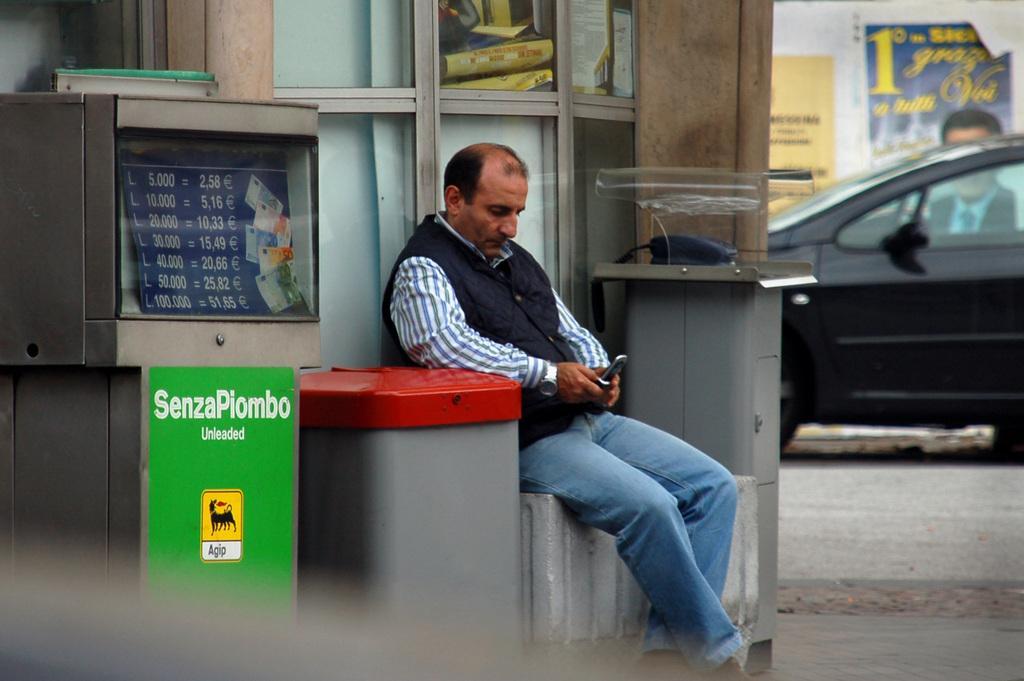Could you give a brief overview of what you see in this image? In the middle of the image we can see a man is seated and he is holding a mobile phone, beside him we can find a dustbin, telephone and few other things, in the background we can see a car and few posters on the wall. 